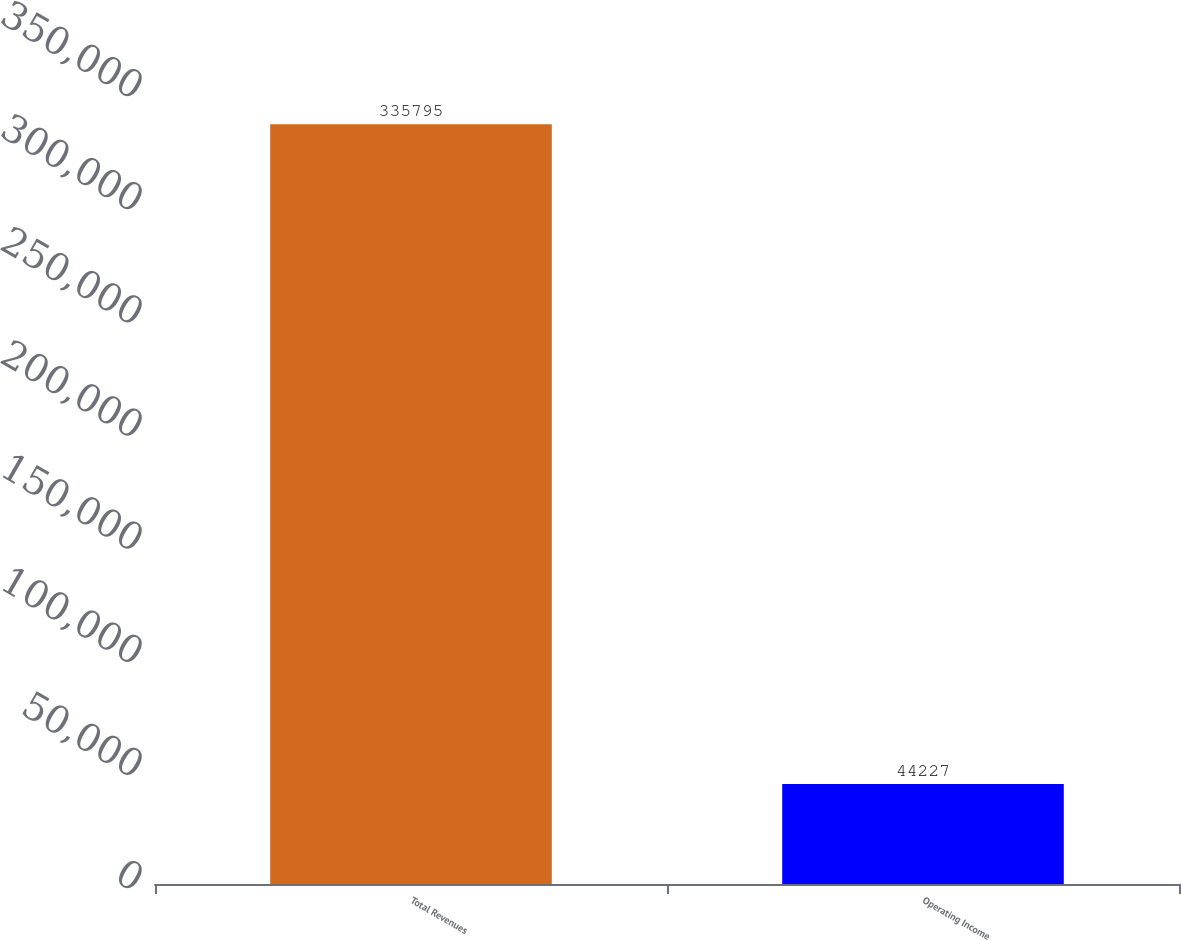Convert chart. <chart><loc_0><loc_0><loc_500><loc_500><bar_chart><fcel>Total Revenues<fcel>Operating Income<nl><fcel>335795<fcel>44227<nl></chart> 